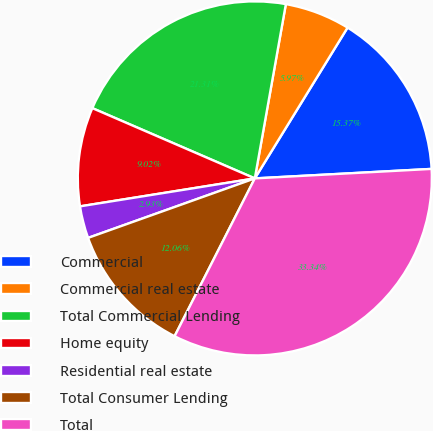Convert chart. <chart><loc_0><loc_0><loc_500><loc_500><pie_chart><fcel>Commercial<fcel>Commercial real estate<fcel>Total Commercial Lending<fcel>Home equity<fcel>Residential real estate<fcel>Total Consumer Lending<fcel>Total<nl><fcel>15.37%<fcel>5.97%<fcel>21.31%<fcel>9.02%<fcel>2.93%<fcel>12.06%<fcel>33.34%<nl></chart> 